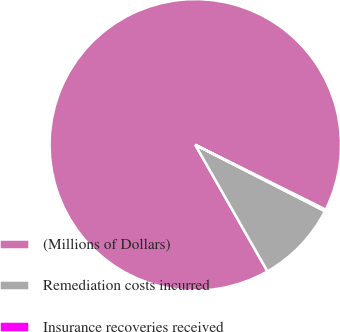Convert chart to OTSL. <chart><loc_0><loc_0><loc_500><loc_500><pie_chart><fcel>(Millions of Dollars)<fcel>Remediation costs incurred<fcel>Insurance recoveries received<nl><fcel>90.6%<fcel>9.22%<fcel>0.18%<nl></chart> 